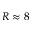Convert formula to latex. <formula><loc_0><loc_0><loc_500><loc_500>R \approx 8</formula> 